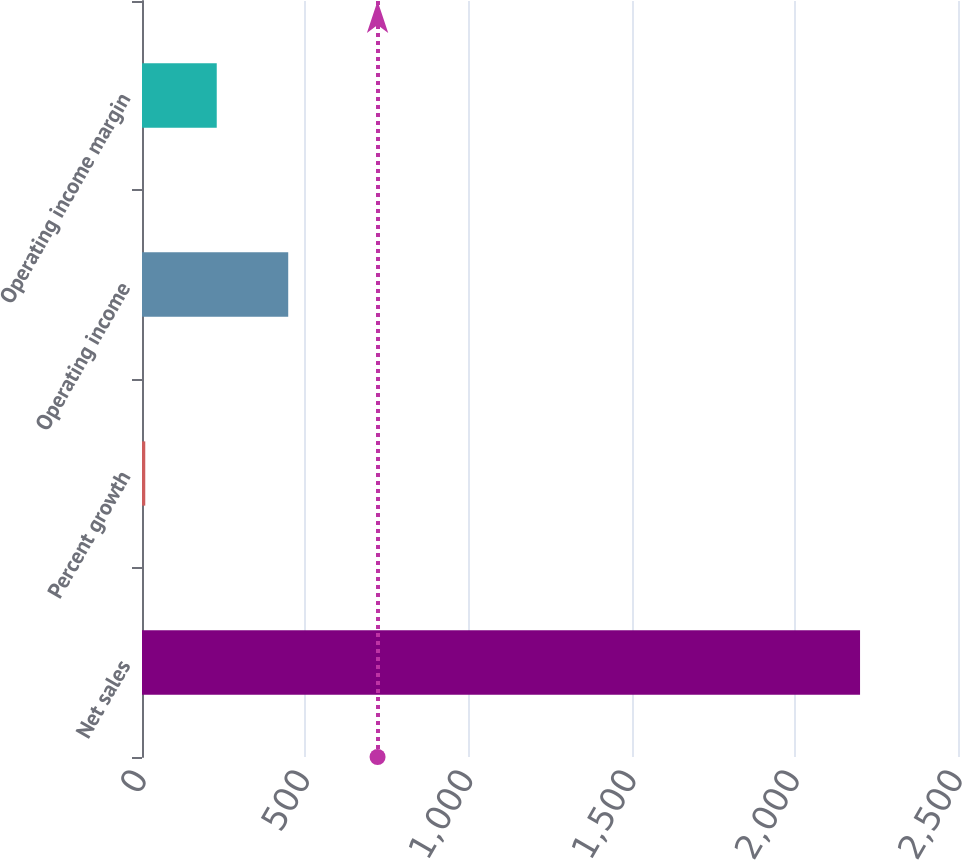Convert chart to OTSL. <chart><loc_0><loc_0><loc_500><loc_500><bar_chart><fcel>Net sales<fcel>Percent growth<fcel>Operating income<fcel>Operating income margin<nl><fcel>2199.9<fcel>10<fcel>447.98<fcel>228.99<nl></chart> 